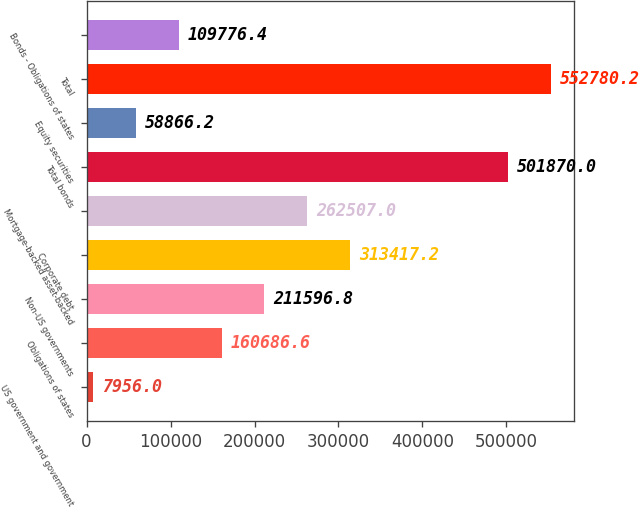<chart> <loc_0><loc_0><loc_500><loc_500><bar_chart><fcel>US government and government<fcel>Obligations of states<fcel>Non-US governments<fcel>Corporate debt<fcel>Mortgage-backed asset-backed<fcel>Total bonds<fcel>Equity securities<fcel>Total<fcel>Bonds - Obligations of states<nl><fcel>7956<fcel>160687<fcel>211597<fcel>313417<fcel>262507<fcel>501870<fcel>58866.2<fcel>552780<fcel>109776<nl></chart> 